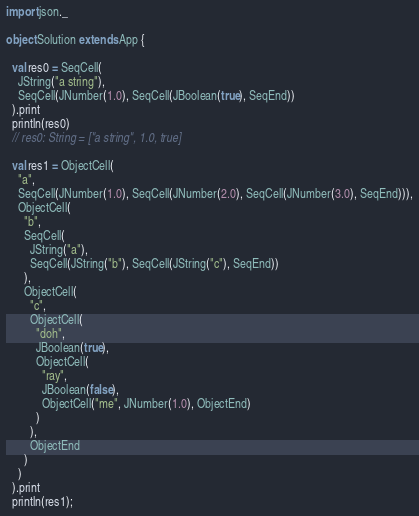<code> <loc_0><loc_0><loc_500><loc_500><_Scala_>import json._

object Solution extends App {

  val res0 = SeqCell(
    JString("a string"),
    SeqCell(JNumber(1.0), SeqCell(JBoolean(true), SeqEnd))
  ).print
  println(res0)
  // res0: String = ["a string", 1.0, true]

  val res1 = ObjectCell(
    "a",
    SeqCell(JNumber(1.0), SeqCell(JNumber(2.0), SeqCell(JNumber(3.0), SeqEnd))),
    ObjectCell(
      "b",
      SeqCell(
        JString("a"),
        SeqCell(JString("b"), SeqCell(JString("c"), SeqEnd))
      ),
      ObjectCell(
        "c",
        ObjectCell(
          "doh",
          JBoolean(true),
          ObjectCell(
            "ray",
            JBoolean(false),
            ObjectCell("me", JNumber(1.0), ObjectEnd)
          )
        ),
        ObjectEnd
      )
    )
  ).print
  println(res1);</code> 